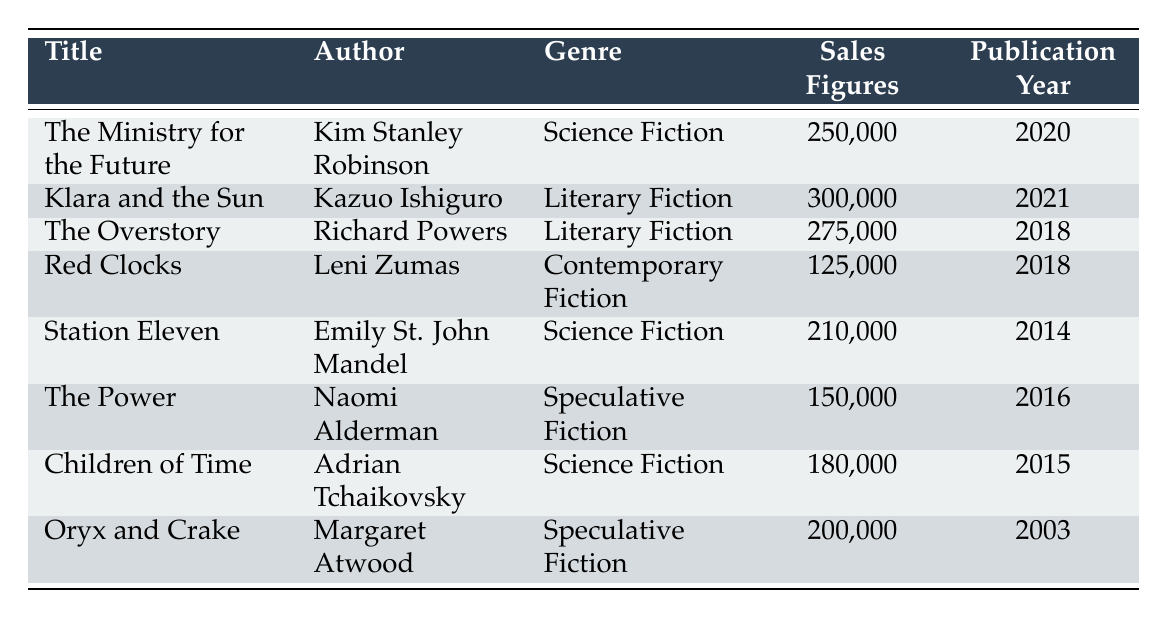What is the title of the dystopian novel with the highest sales figures in 2022? According to the table, the title with the highest sales figures is "Klara and the Sun" with sales of 300,000.
Answer: Klara and the Sun Which author wrote "Children of Time"? The author of "Children of Time" is Adrian Tchaikovsky, as listed in the table.
Answer: Adrian Tchaikovsky How many Science Fiction novels were listed in the table? The table lists three Science Fiction novels: "The Ministry for the Future," "Station Eleven," and "Children of Time."
Answer: 3 What is the total sales figure for Literary Fiction novels? The sales figures for Literary Fiction novels are 300,000 (Klara and the Sun) and 275,000 (The Overstory). Adding these gives 300,000 + 275,000 = 575,000.
Answer: 575,000 Is "Oryx and Crake" a Science Fiction novel? According to the table, "Oryx and Crake" is categorized under Speculative Fiction, not Science Fiction.
Answer: No What is the average sales figure for Speculative Fiction novels? The table includes two Speculative Fiction novels: "The Power" with sales of 150,000 and "Oryx and Crake" with sales of 200,000. The average is (150,000 + 200,000) / 2 = 175,000.
Answer: 175,000 Which genre has the lowest sales figure in the table? The only Contemporary Fiction novel listed is "Red Clocks" with sales figures of 125,000, and no other genre has sales lower than this.
Answer: Contemporary Fiction How many novels published after 2015 sold more than 200,000 copies? The novels published after 2015 are "Klara and the Sun" (300,000), "The Power" (150,000), and "Children of Time" (180,000). Only "Klara and the Sun" sold more than 200,000.
Answer: 1 